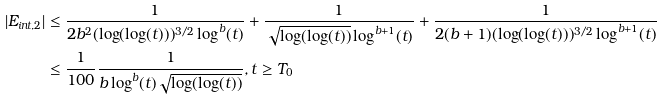Convert formula to latex. <formula><loc_0><loc_0><loc_500><loc_500>| E _ { i n t , 2 } | & \leq \frac { 1 } { 2 b ^ { 2 } ( \log ( \log ( t ) ) ) ^ { 3 / 2 } \log ^ { b } ( t ) } + \frac { 1 } { \sqrt { \log ( \log ( t ) ) } \log ^ { b + 1 } ( t ) } + \frac { 1 } { 2 ( b + 1 ) ( \log ( \log ( t ) ) ) ^ { 3 / 2 } \log ^ { b + 1 } ( t ) } \\ & \leq \frac { 1 } { 1 0 0 } \frac { 1 } { b \log ^ { b } ( t ) \sqrt { \log ( \log ( t ) ) } } , t \geq T _ { 0 }</formula> 